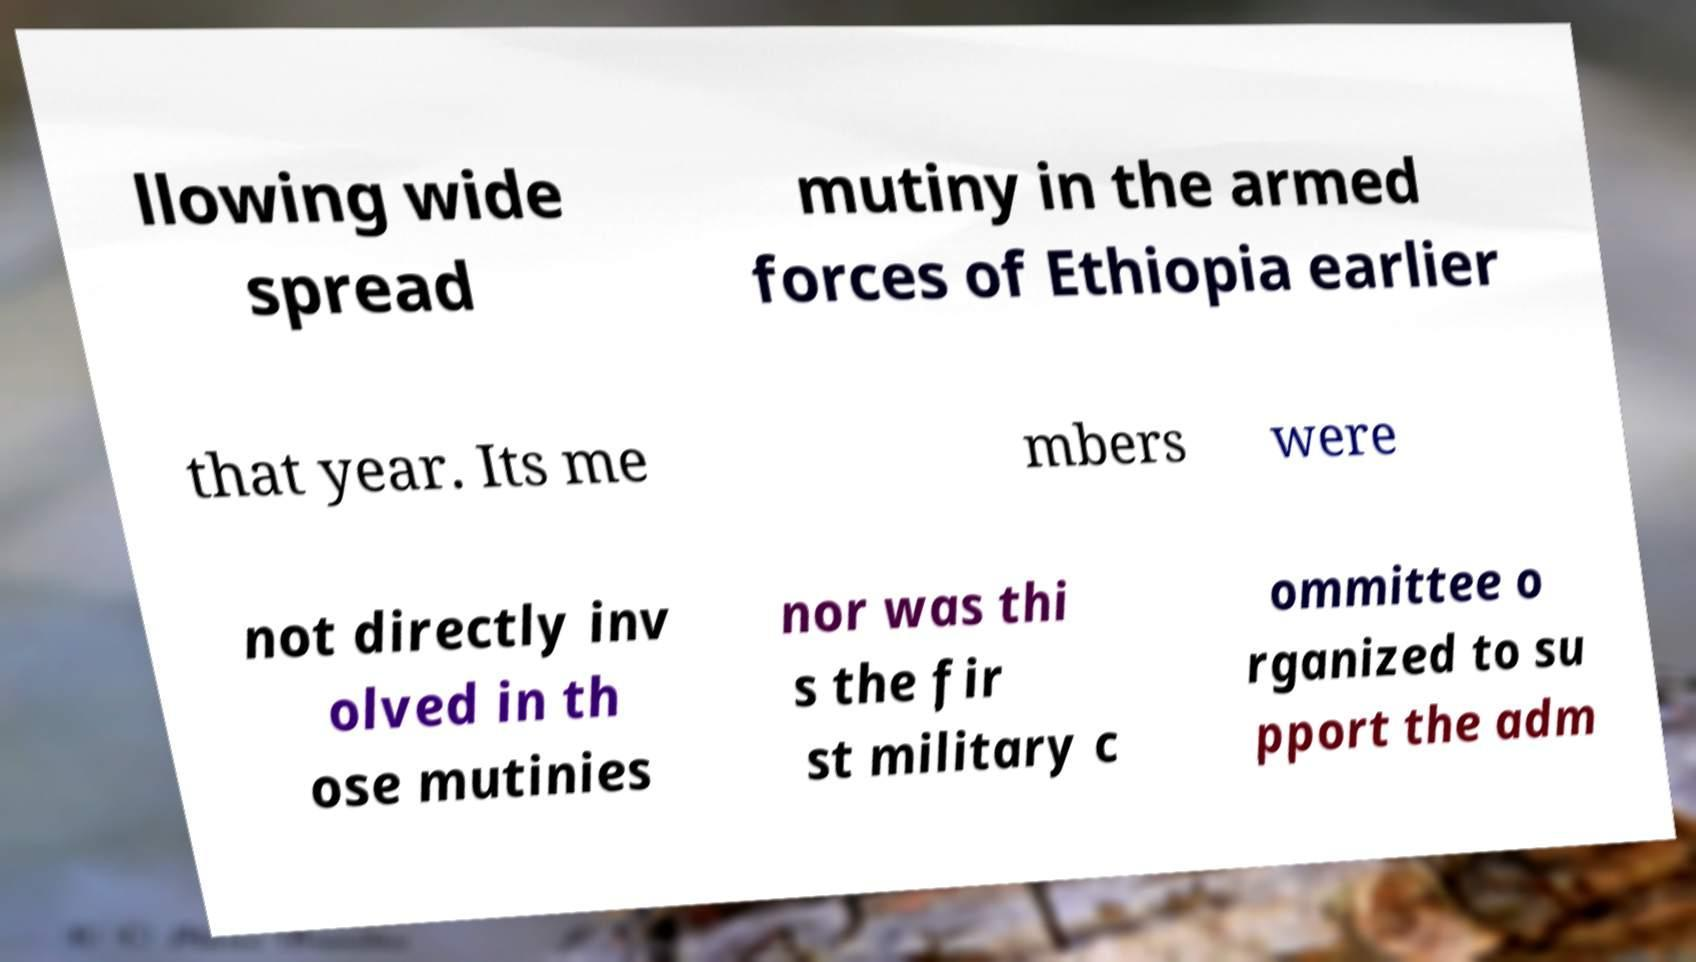Please identify and transcribe the text found in this image. llowing wide spread mutiny in the armed forces of Ethiopia earlier that year. Its me mbers were not directly inv olved in th ose mutinies nor was thi s the fir st military c ommittee o rganized to su pport the adm 